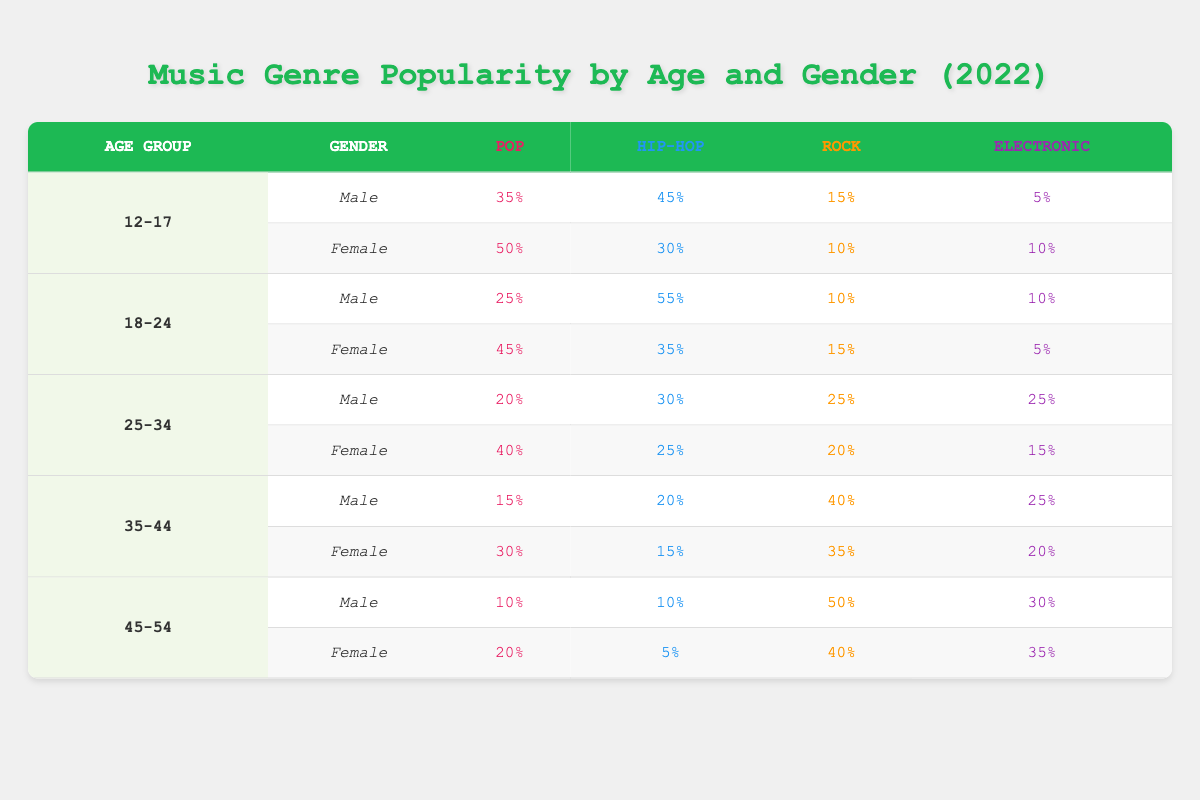What is the most popular music genre among 12-17-year-old males? According to the table, 12-17-year-old males prefer Hip-Hop the most, with a popularity rating of 45%.
Answer: Hip-Hop Which gender preferred Pop more among the 18-24 age group? Analyzing the ratings in the 18-24 column, females have a higher preference for Pop at 45%, compared to males who have a preference of 25%.
Answer: Female What is the difference in popularity for Rock between 35-44-year-old males and females? The table shows that Rock is rated at 40% for males and 35% for females. Therefore, the difference is 40% - 35% = 5%.
Answer: 5% Is Hip-Hop more popular than Electronic among 25-34-year-old females? The table indicates that Hip-Hop is rated at 25% while Electronic is rated at 15%. Since 25% is greater than 15%, Hip-Hop is more popular.
Answer: Yes What are the average popularity ratings for Pop across all age groups and genders? To find the average, we sum the Pop ratings: 35 + 50 + 25 + 45 + 20 + 40 + 15 + 30 + 10 + 20 = 350. There are 10 groups, so the average is 350/10 = 35%.
Answer: 35% 